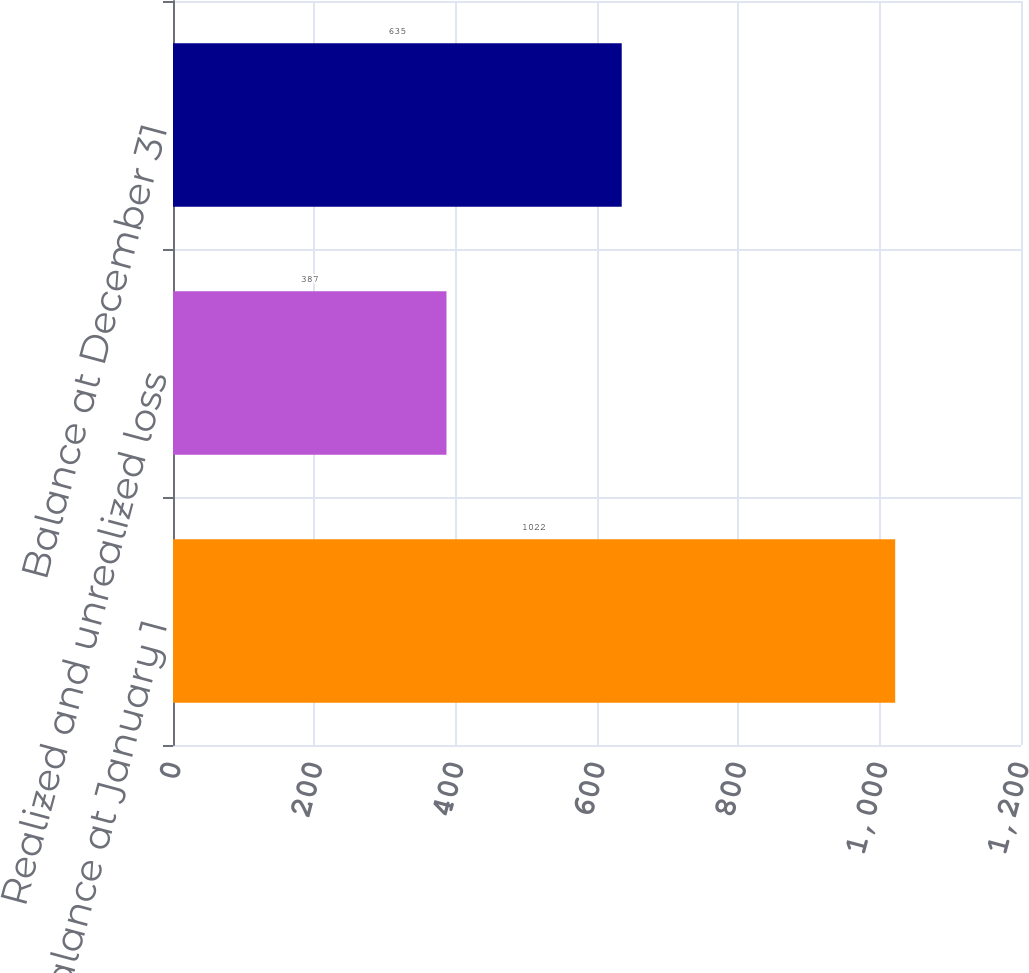<chart> <loc_0><loc_0><loc_500><loc_500><bar_chart><fcel>Balance at January 1<fcel>Realized and unrealized loss<fcel>Balance at December 31<nl><fcel>1022<fcel>387<fcel>635<nl></chart> 